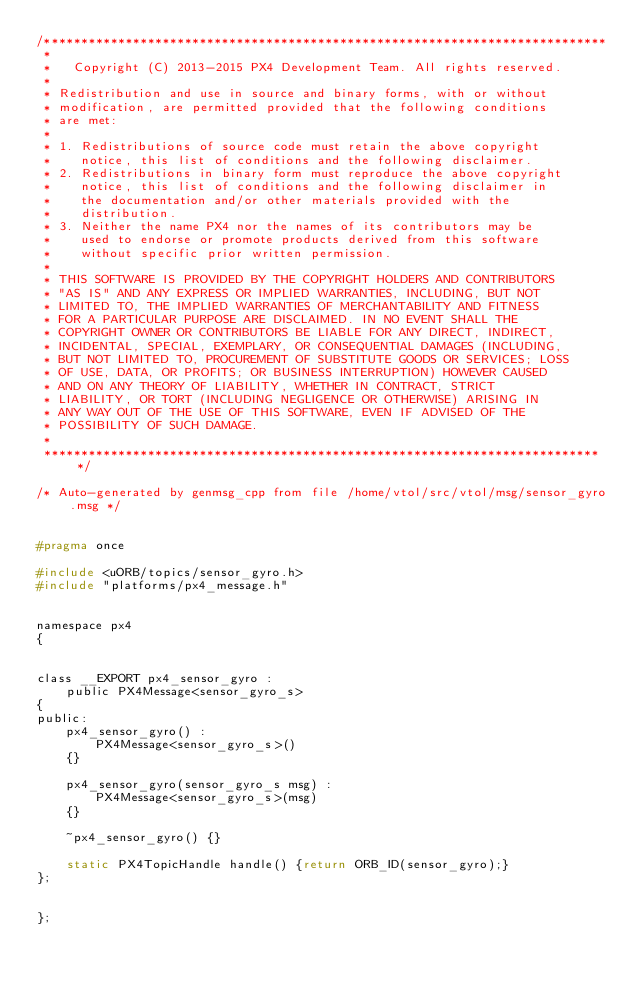<code> <loc_0><loc_0><loc_500><loc_500><_C_>/****************************************************************************
 *
 *   Copyright (C) 2013-2015 PX4 Development Team. All rights reserved.
 *
 * Redistribution and use in source and binary forms, with or without
 * modification, are permitted provided that the following conditions
 * are met:
 *
 * 1. Redistributions of source code must retain the above copyright
 *    notice, this list of conditions and the following disclaimer.
 * 2. Redistributions in binary form must reproduce the above copyright
 *    notice, this list of conditions and the following disclaimer in
 *    the documentation and/or other materials provided with the
 *    distribution.
 * 3. Neither the name PX4 nor the names of its contributors may be
 *    used to endorse or promote products derived from this software
 *    without specific prior written permission.
 *
 * THIS SOFTWARE IS PROVIDED BY THE COPYRIGHT HOLDERS AND CONTRIBUTORS
 * "AS IS" AND ANY EXPRESS OR IMPLIED WARRANTIES, INCLUDING, BUT NOT
 * LIMITED TO, THE IMPLIED WARRANTIES OF MERCHANTABILITY AND FITNESS
 * FOR A PARTICULAR PURPOSE ARE DISCLAIMED. IN NO EVENT SHALL THE
 * COPYRIGHT OWNER OR CONTRIBUTORS BE LIABLE FOR ANY DIRECT, INDIRECT,
 * INCIDENTAL, SPECIAL, EXEMPLARY, OR CONSEQUENTIAL DAMAGES (INCLUDING,
 * BUT NOT LIMITED TO, PROCUREMENT OF SUBSTITUTE GOODS OR SERVICES; LOSS
 * OF USE, DATA, OR PROFITS; OR BUSINESS INTERRUPTION) HOWEVER CAUSED
 * AND ON ANY THEORY OF LIABILITY, WHETHER IN CONTRACT, STRICT
 * LIABILITY, OR TORT (INCLUDING NEGLIGENCE OR OTHERWISE) ARISING IN
 * ANY WAY OUT OF THE USE OF THIS SOFTWARE, EVEN IF ADVISED OF THE
 * POSSIBILITY OF SUCH DAMAGE.
 *
 ****************************************************************************/

/* Auto-generated by genmsg_cpp from file /home/vtol/src/vtol/msg/sensor_gyro.msg */


#pragma once

#include <uORB/topics/sensor_gyro.h>
#include "platforms/px4_message.h"


namespace px4
{


class __EXPORT px4_sensor_gyro :
	public PX4Message<sensor_gyro_s>
{
public:
	px4_sensor_gyro() :
		PX4Message<sensor_gyro_s>()
	{}

	px4_sensor_gyro(sensor_gyro_s msg) :
		PX4Message<sensor_gyro_s>(msg)
	{}

	~px4_sensor_gyro() {}

	static PX4TopicHandle handle() {return ORB_ID(sensor_gyro);}
};


};
</code> 